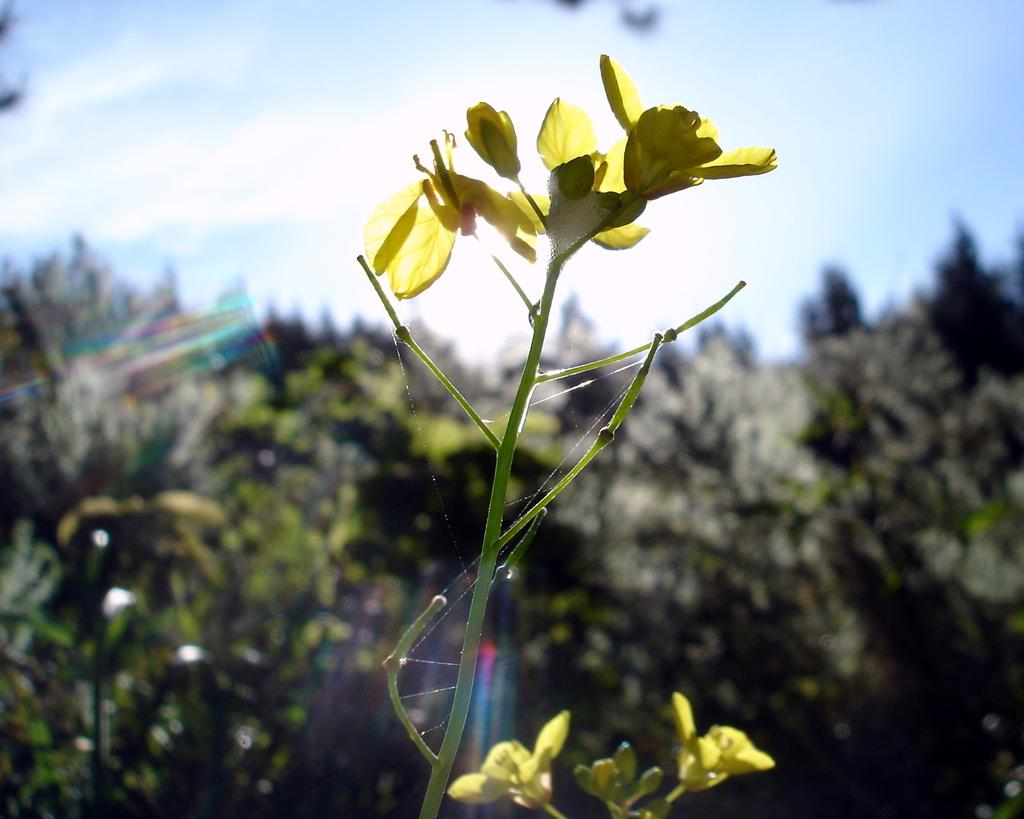What type of living organisms can be seen in the image? There are flowers on a plant in the image. What can be seen in the background of the image? There are trees visible in the background of the image. How many kisses can be seen on the flowers in the image? There are no kisses present on the flowers in the image. What type of ink is used to color the trees in the background of the image? There is no ink used in the image, as it is a photograph and not a drawing or painting. 